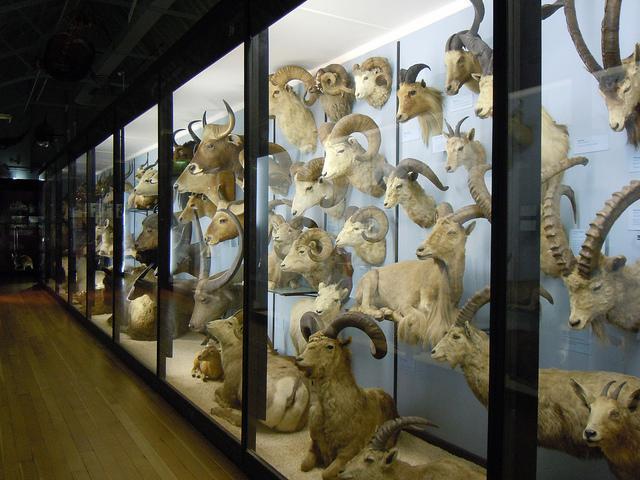What form of art was used to preserve these dead animals?
Choose the right answer and clarify with the format: 'Answer: answer
Rationale: rationale.'
Options: Taxidermy, metalworking, sculpting, drawing. Answer: taxidermy.
Rationale: These are stuffed dead animals which is called taxidermy. 